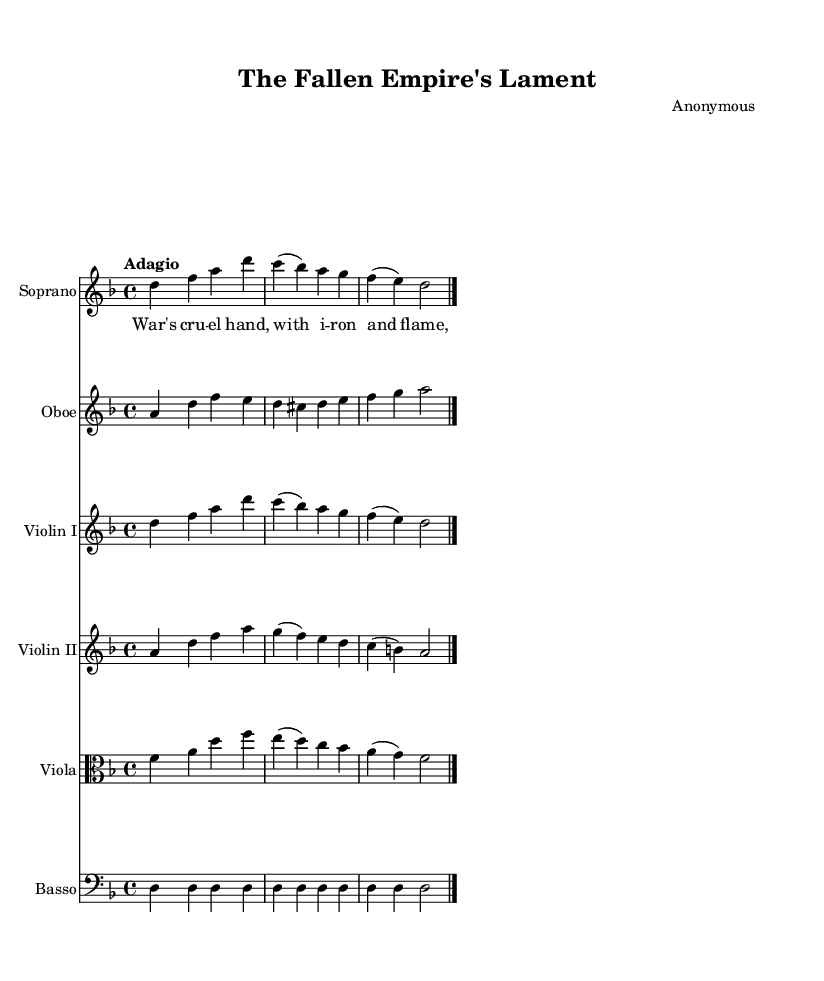What is the key signature of this music? The key signature is identified at the beginning of the staff where the sharps or flats are indicated. In this case, it shows one flat, which designates the key of D minor.
Answer: D minor What is the time signature of this piece? The time signature appears at the beginning of the music, represented as a fraction. It shows "4/4", meaning there are four beats in a measure and the quarter note gets one beat.
Answer: 4/4 What is the tempo marking of this piece? The tempo marking is found at the beginning of the score, indicating how fast the piece should be played. Here it is marked as "Adagio," which means it should be played slowly.
Answer: Adagio How many instruments are present in this score? The score lists multiple staves, each indicating a separate instrument part. Counting these, there are five distinct staves for different instruments.
Answer: Five What type of music is this piece classified as? Examining the structure and intent of the piece, it is written for multiple voices and instruments, characteristic of Baroque cantatas, which often reflect themes influenced by religious or historical context.
Answer: Cantata What is the main theme expressed in the lyrics? The lyrics depict scenes of war and its consequences, conveying a somber reflection on the downfall of empires due to conflict. The phrasing and emotion in the text highlight loss and tragedy.
Answer: Loss and tragedy What is the role of the basso in this piece? The basso provides the harmonic foundation for the rest of the instruments. It typically supports the melody and other harmonic parts, maintaining a steady presence throughout the piece.
Answer: Harmonic foundation 